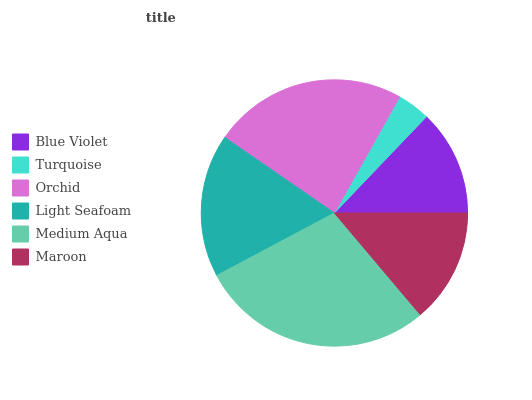Is Turquoise the minimum?
Answer yes or no. Yes. Is Medium Aqua the maximum?
Answer yes or no. Yes. Is Orchid the minimum?
Answer yes or no. No. Is Orchid the maximum?
Answer yes or no. No. Is Orchid greater than Turquoise?
Answer yes or no. Yes. Is Turquoise less than Orchid?
Answer yes or no. Yes. Is Turquoise greater than Orchid?
Answer yes or no. No. Is Orchid less than Turquoise?
Answer yes or no. No. Is Light Seafoam the high median?
Answer yes or no. Yes. Is Maroon the low median?
Answer yes or no. Yes. Is Orchid the high median?
Answer yes or no. No. Is Blue Violet the low median?
Answer yes or no. No. 